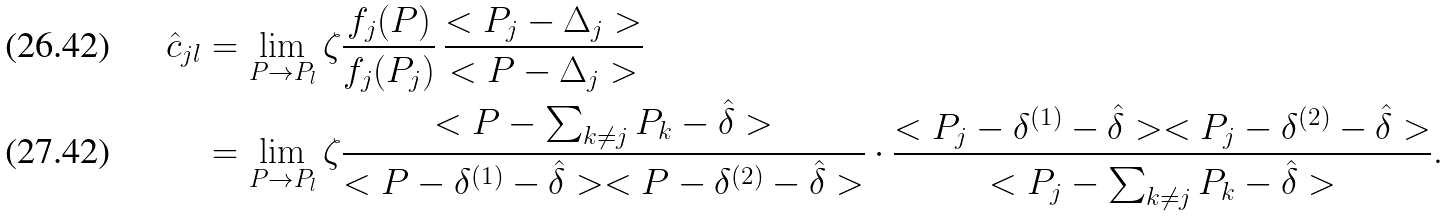<formula> <loc_0><loc_0><loc_500><loc_500>\hat { c } _ { j l } & = \lim _ { P \rightarrow P _ { l } } \zeta \frac { f _ { j } ( P ) } { f _ { j } ( P _ { j } ) } \, \frac { < P _ { j } - \Delta _ { j } > } { < P - \Delta _ { j } > } \\ & = \lim _ { P \rightarrow P _ { l } } \zeta \frac { < P - \sum _ { k \neq j } P _ { k } - \hat { \delta } > } { < P - \delta ^ { ( 1 ) } - \hat { \delta } > < P - \delta ^ { ( 2 ) } - \hat { \delta } > } \cdot \frac { < P _ { j } - \delta ^ { ( 1 ) } - \hat { \delta } > < P _ { j } - \delta ^ { ( 2 ) } - \hat { \delta } > } { < P _ { j } - \sum _ { k \neq j } P _ { k } - \hat { \delta } > } .</formula> 